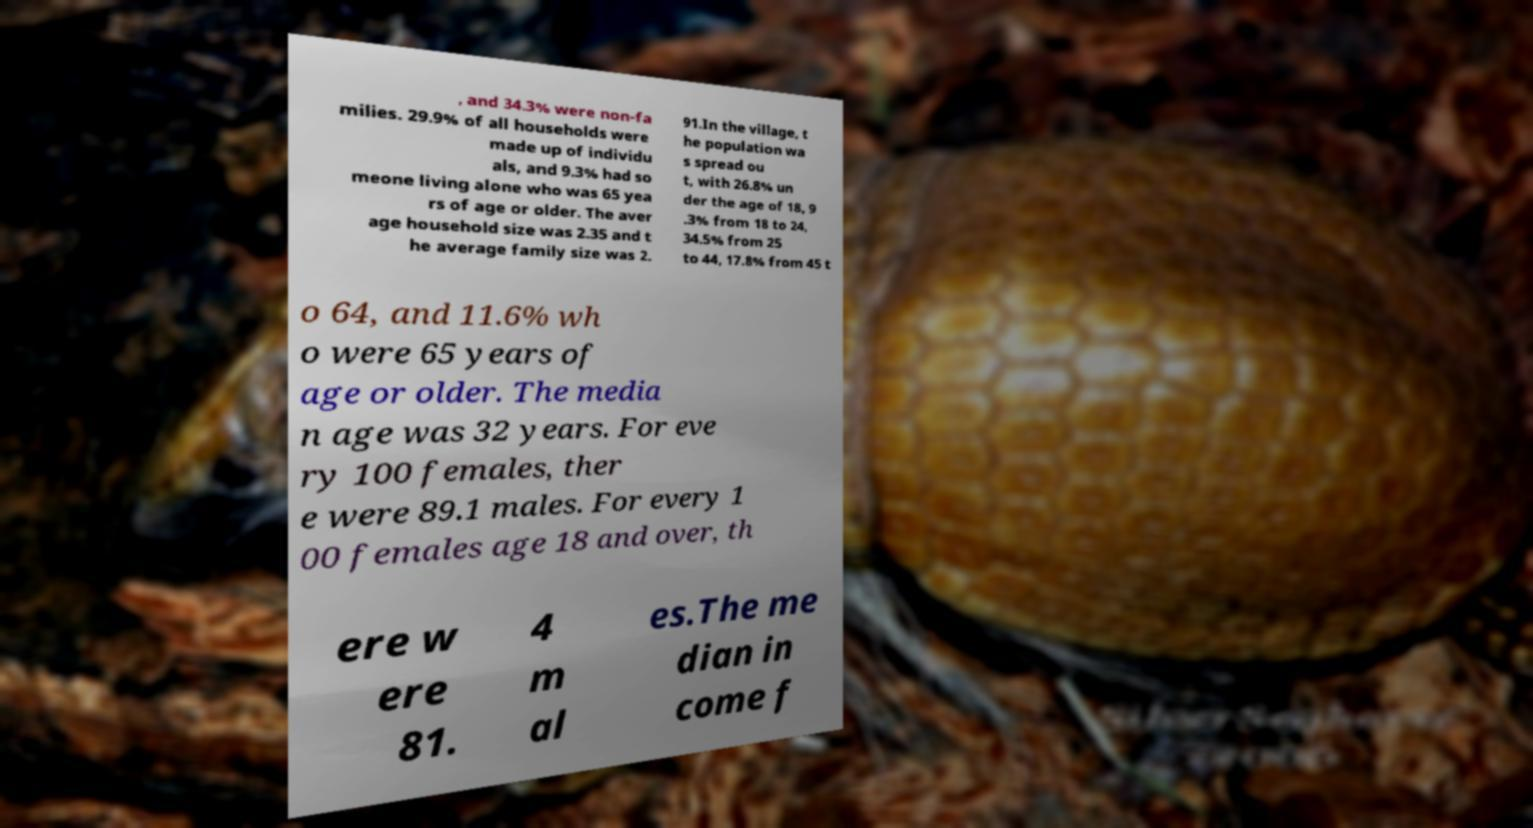For documentation purposes, I need the text within this image transcribed. Could you provide that? , and 34.3% were non-fa milies. 29.9% of all households were made up of individu als, and 9.3% had so meone living alone who was 65 yea rs of age or older. The aver age household size was 2.35 and t he average family size was 2. 91.In the village, t he population wa s spread ou t, with 26.8% un der the age of 18, 9 .3% from 18 to 24, 34.5% from 25 to 44, 17.8% from 45 t o 64, and 11.6% wh o were 65 years of age or older. The media n age was 32 years. For eve ry 100 females, ther e were 89.1 males. For every 1 00 females age 18 and over, th ere w ere 81. 4 m al es.The me dian in come f 